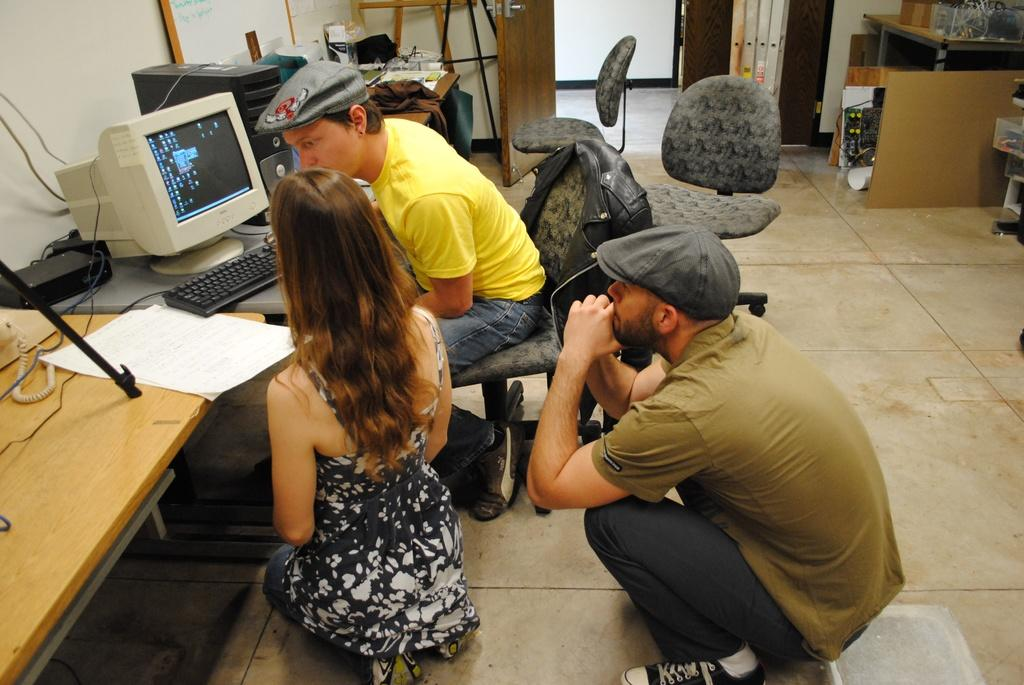How many people are in the image? There are people in the image, but the exact number is not specified. What positions are the people in? Some people are sitting on chairs, while others are sitting on the floor. Can you describe the seating arrangement in the image? The people are sitting in a combination of chairs and on the floor. What type of crayon is being used by the people in the image? There is no mention of crayons or any drawing activity in the image. 